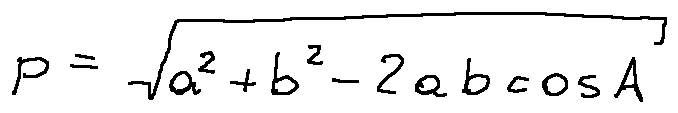Convert formula to latex. <formula><loc_0><loc_0><loc_500><loc_500>p = \sqrt { a ^ { 2 } + b ^ { 2 } - 2 a b \cos A }</formula> 